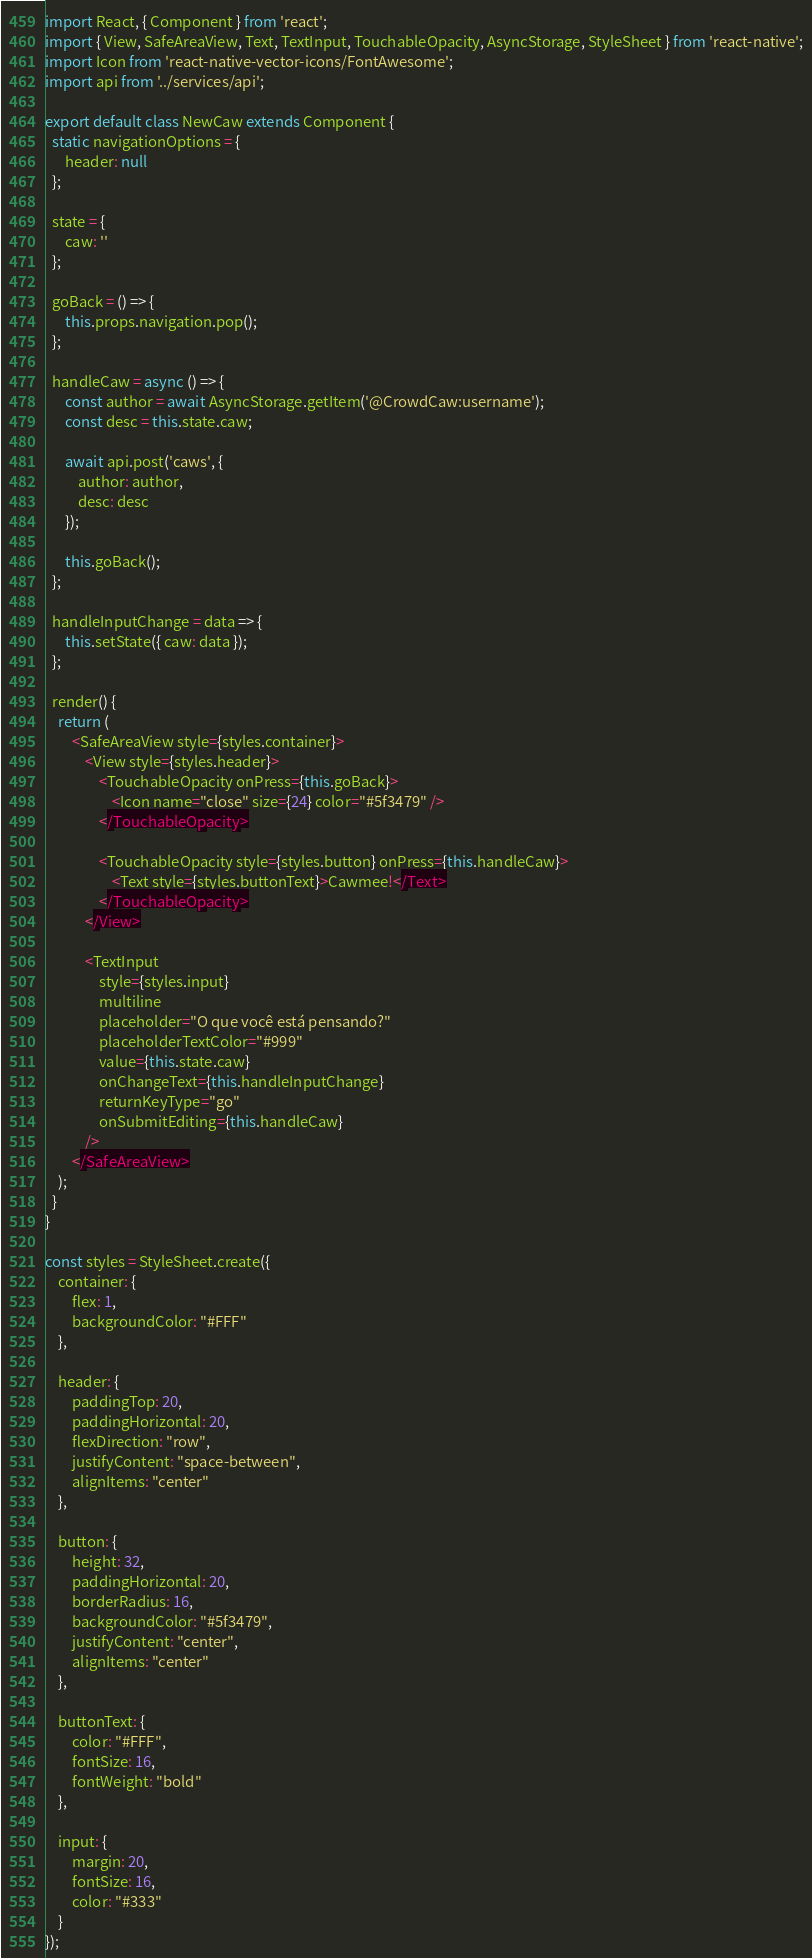<code> <loc_0><loc_0><loc_500><loc_500><_JavaScript_>import React, { Component } from 'react';
import { View, SafeAreaView, Text, TextInput, TouchableOpacity, AsyncStorage, StyleSheet } from 'react-native';
import Icon from 'react-native-vector-icons/FontAwesome';
import api from '../services/api';

export default class NewCaw extends Component {
  static navigationOptions = {
      header: null
  };

  state = {
      caw: ''
  };

  goBack = () => {
      this.props.navigation.pop();
  };

  handleCaw = async () => {
      const author = await AsyncStorage.getItem('@CrowdCaw:username');
      const desc = this.state.caw;

      await api.post('caws', {
          author: author,
          desc: desc
      });

      this.goBack();
  };

  handleInputChange = data => {
      this.setState({ caw: data });
  };

  render() {
    return (
        <SafeAreaView style={styles.container}>
            <View style={styles.header}>
                <TouchableOpacity onPress={this.goBack}>
                    <Icon name="close" size={24} color="#5f3479" />
                </TouchableOpacity>

                <TouchableOpacity style={styles.button} onPress={this.handleCaw}>
                    <Text style={styles.buttonText}>Cawmee!</Text>
                </TouchableOpacity>
            </View>

            <TextInput 
                style={styles.input} 
                multiline
                placeholder="O que você está pensando?"
                placeholderTextColor="#999"
                value={this.state.caw}
                onChangeText={this.handleInputChange}
                returnKeyType="go"
                onSubmitEditing={this.handleCaw}
            />
        </SafeAreaView>
    );
  }
}

const styles = StyleSheet.create({
    container: {
        flex: 1,
        backgroundColor: "#FFF"
    },

    header: {
        paddingTop: 20,
        paddingHorizontal: 20,
        flexDirection: "row",
        justifyContent: "space-between",
        alignItems: "center"
    },

    button: {
        height: 32,
        paddingHorizontal: 20,
        borderRadius: 16,
        backgroundColor: "#5f3479",
        justifyContent: "center",
        alignItems: "center"
    },

    buttonText: {
        color: "#FFF",
        fontSize: 16,
        fontWeight: "bold"
    },

    input: {
        margin: 20,
        fontSize: 16,
        color: "#333"
    }
});  
</code> 